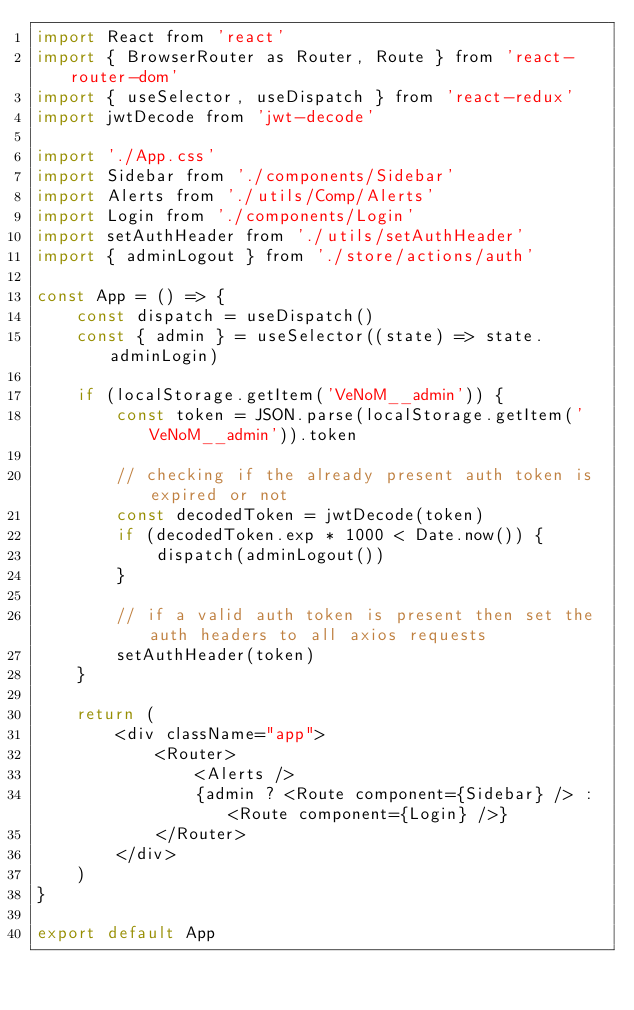<code> <loc_0><loc_0><loc_500><loc_500><_JavaScript_>import React from 'react'
import { BrowserRouter as Router, Route } from 'react-router-dom'
import { useSelector, useDispatch } from 'react-redux'
import jwtDecode from 'jwt-decode'

import './App.css'
import Sidebar from './components/Sidebar'
import Alerts from './utils/Comp/Alerts'
import Login from './components/Login'
import setAuthHeader from './utils/setAuthHeader'
import { adminLogout } from './store/actions/auth'

const App = () => {
    const dispatch = useDispatch()
    const { admin } = useSelector((state) => state.adminLogin)

    if (localStorage.getItem('VeNoM__admin')) {
        const token = JSON.parse(localStorage.getItem('VeNoM__admin')).token

        // checking if the already present auth token is expired or not
        const decodedToken = jwtDecode(token)
        if (decodedToken.exp * 1000 < Date.now()) {
            dispatch(adminLogout())
        }

        // if a valid auth token is present then set the auth headers to all axios requests
        setAuthHeader(token)
    }

    return (
        <div className="app">
            <Router>
                <Alerts />
                {admin ? <Route component={Sidebar} /> : <Route component={Login} />}
            </Router>
        </div>
    )
}

export default App
</code> 